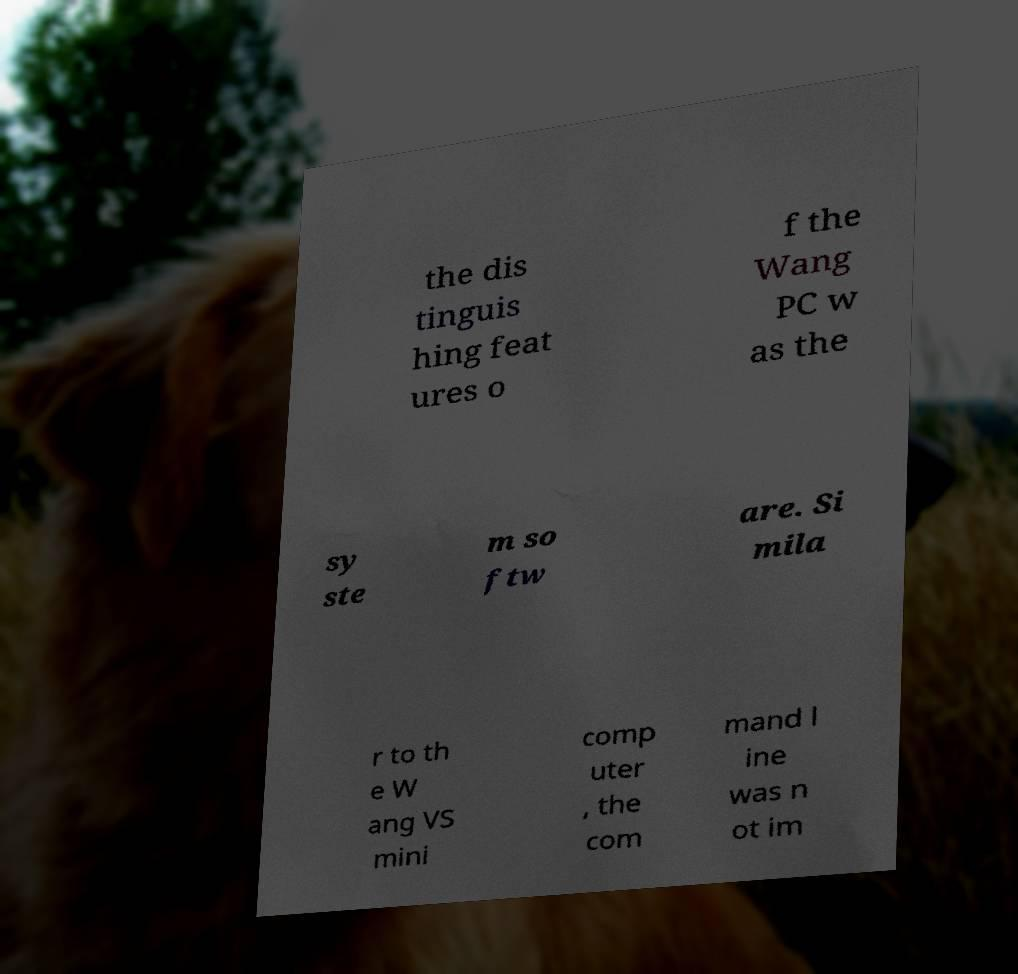Please identify and transcribe the text found in this image. the dis tinguis hing feat ures o f the Wang PC w as the sy ste m so ftw are. Si mila r to th e W ang VS mini comp uter , the com mand l ine was n ot im 